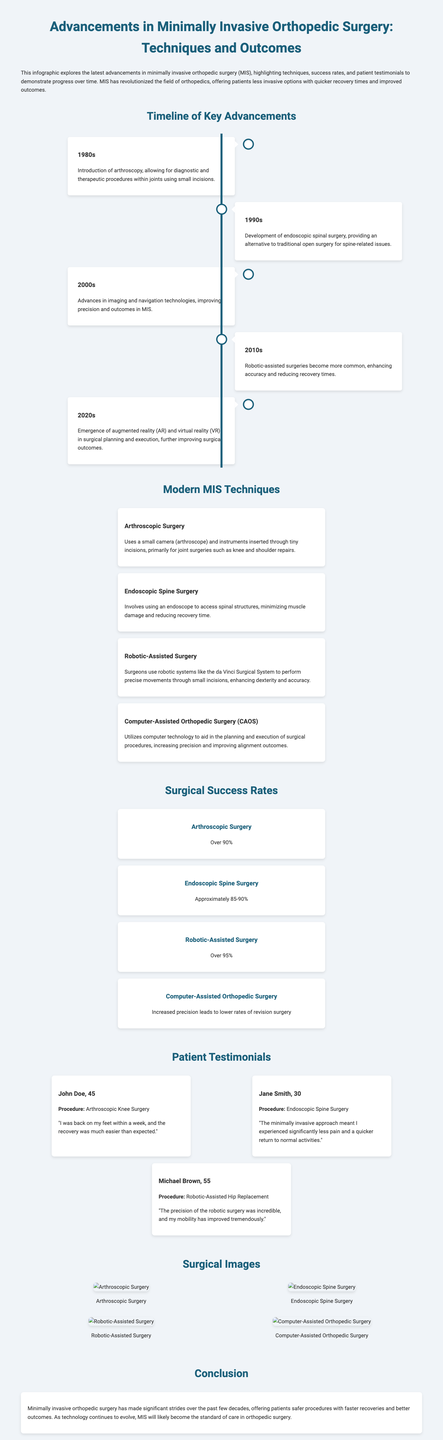What year did the introduction of arthroscopy occur? The timeline indicates that the introduction of arthroscopy occurred in the 1980s.
Answer: 1980s What is the success rate of robotic-assisted surgery? The document states that the success rate of robotic-assisted surgery is over 95%.
Answer: Over 95% Which procedure experienced significantly less pain and quicker recovery according to the testimonial? Jane Smith's testimonial indicates that the endoscopic spine surgery led to significantly less pain and a quicker return to normal activities.
Answer: Endoscopic Spine Surgery What technology emerged in the 2020s that enhanced surgical outcomes? The document mentions that augmented reality (AR) and virtual reality (VR) emerged in the 2020s for surgical planning and execution.
Answer: Augmented reality and virtual reality What type of surgery uses a small camera and instruments inserted through tiny incisions? The document specifies that arthroscopic surgery uses a small camera (arthroscope) and instruments inserted through tiny incisions.
Answer: Arthroscopic Surgery What procedure is mentioned for John Doe in the testimonials? The testimonial section identifies that John Doe underwent arthroscopic knee surgery.
Answer: Arthroscopic Knee Surgery What advancement occurred in the 2010s related to surgical procedures? The timeline states that robotic-assisted surgeries became more common in the 2010s.
Answer: Robotic-assisted surgeries How many testimonials are featured in the document? The document includes three testimonials from different patients.
Answer: Three 